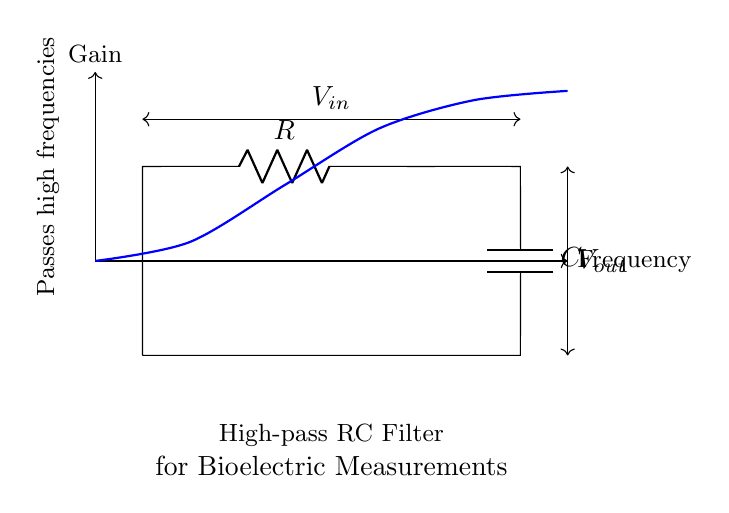What are the components in this circuit? The circuit consists of a resistor and a capacitor as indicated by the labels R and C in the diagram. Resistors and capacitors are standard passive electrical components typically represented in this manner.
Answer: Resistor and Capacitor What is the function of this circuit? The circuit is a high-pass filter, as denoted by the title "High-pass RC Filter" in the diagram, which allows high-frequency signals to pass while attenuating low-frequency signals.
Answer: High-pass filter What is the input voltage denoted as? The input voltage in the circuit is labeled as V_in, which is the voltage supplied to the circuit and is represented by the arrow connected to the left side of the circuit.
Answer: V_in What does V_out represent in this context? V_out represents the output voltage, which is taken from the junction of the resistor and capacitor, indicating the voltage level available for further processing after filtering.
Answer: V_out What happens to low-frequency signals in this circuit? Low-frequency signals are attenuated or blocked by the high-pass filter behavior of the RC circuit, which is designed to prevent such signals from passing through to the output.
Answer: Attenuated At what point is high-frequency signals effectively passed in this circuit? High-frequency signals are effectively passed through at the output V_out, as the circuit is designed to allow these frequencies to go through while blocking lower frequencies.
Answer: At V_out What does the blue curve in the diagram signify? The blue curve represents the gain versus frequency response of the high-pass filter, indicating that the gain increases with frequency, showing how effectively the circuit can pass high frequencies.
Answer: Gain versus frequency 